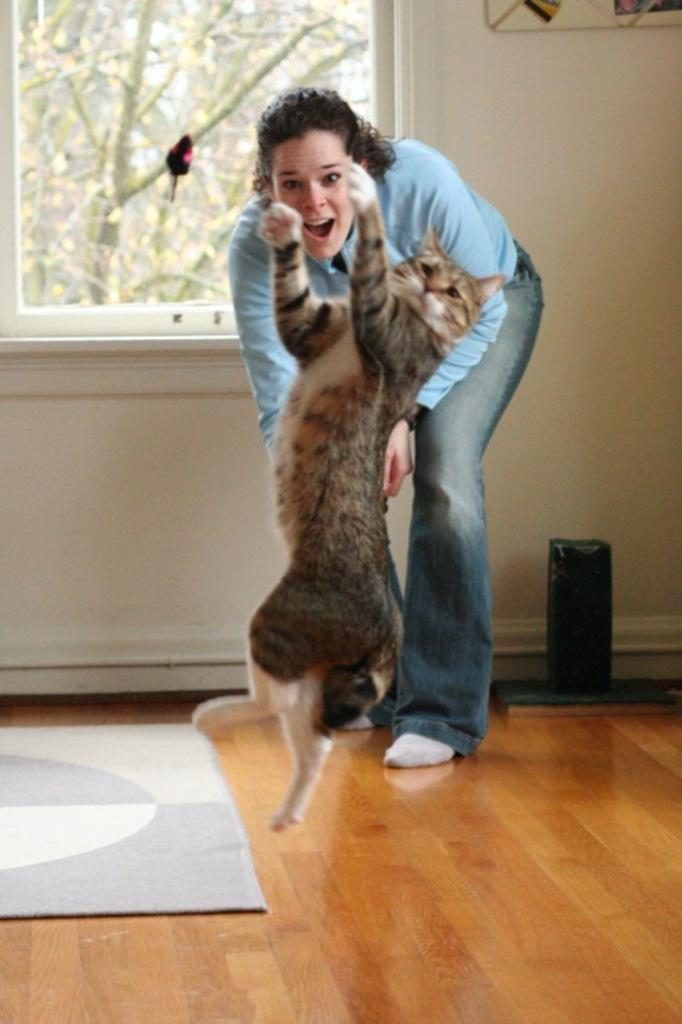What type of animal is present in the image? There is a cat in the image. What is the cat doing in the image? The cat is jumping. Who else is present in the image besides the cat? There is a person in the image. What can be seen in the background of the image? There is an object, a floor, a window, a bird, and branches visible through the window. How many vans are parked outside the window in the image? There are no vans visible in the image; only a bird and branches can be seen through the window. What type of cast is on the person's arm in the image? There is no cast present on the person's arm in the image. 